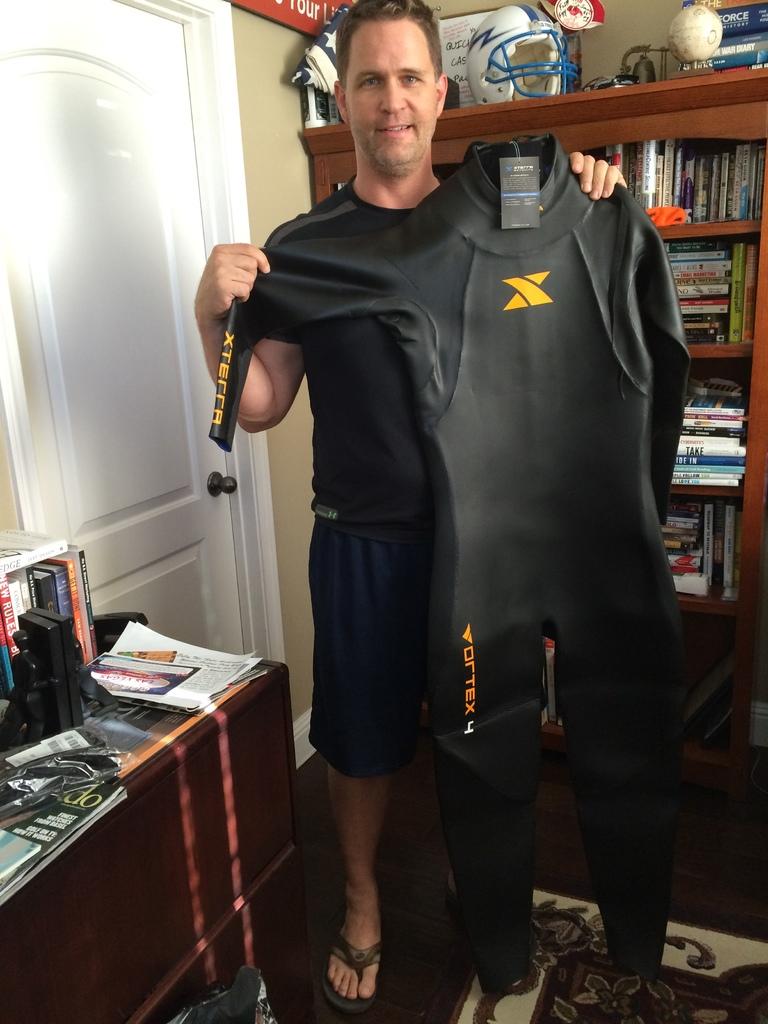What brand is the suit?
Ensure brevity in your answer.  Vortex. 